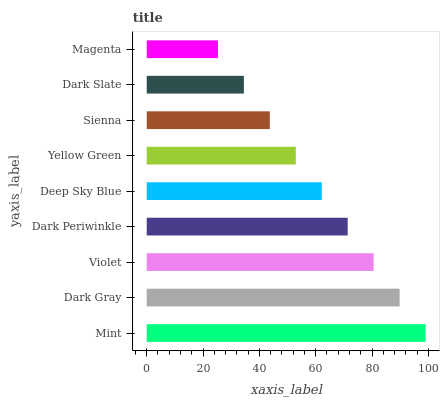Is Magenta the minimum?
Answer yes or no. Yes. Is Mint the maximum?
Answer yes or no. Yes. Is Dark Gray the minimum?
Answer yes or no. No. Is Dark Gray the maximum?
Answer yes or no. No. Is Mint greater than Dark Gray?
Answer yes or no. Yes. Is Dark Gray less than Mint?
Answer yes or no. Yes. Is Dark Gray greater than Mint?
Answer yes or no. No. Is Mint less than Dark Gray?
Answer yes or no. No. Is Deep Sky Blue the high median?
Answer yes or no. Yes. Is Deep Sky Blue the low median?
Answer yes or no. Yes. Is Sienna the high median?
Answer yes or no. No. Is Violet the low median?
Answer yes or no. No. 